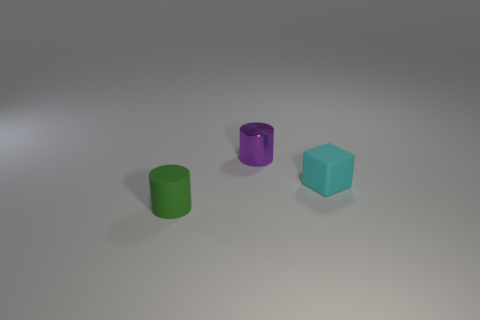Add 2 cylinders. How many objects exist? 5 Add 2 tiny gray metallic objects. How many tiny gray metallic objects exist? 2 Subtract 0 cyan balls. How many objects are left? 3 Subtract all cylinders. How many objects are left? 1 Subtract all cyan cylinders. Subtract all cyan balls. How many cylinders are left? 2 Subtract all big brown balls. Subtract all tiny matte objects. How many objects are left? 1 Add 3 cyan blocks. How many cyan blocks are left? 4 